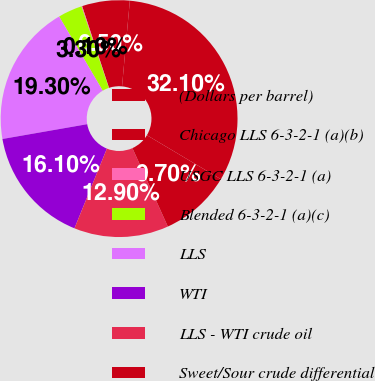Convert chart to OTSL. <chart><loc_0><loc_0><loc_500><loc_500><pie_chart><fcel>(Dollars per barrel)<fcel>Chicago LLS 6-3-2-1 (a)(b)<fcel>USGC LLS 6-3-2-1 (a)<fcel>Blended 6-3-2-1 (a)(c)<fcel>LLS<fcel>WTI<fcel>LLS - WTI crude oil<fcel>Sweet/Sour crude differential<nl><fcel>32.1%<fcel>6.5%<fcel>0.1%<fcel>3.3%<fcel>19.3%<fcel>16.1%<fcel>12.9%<fcel>9.7%<nl></chart> 